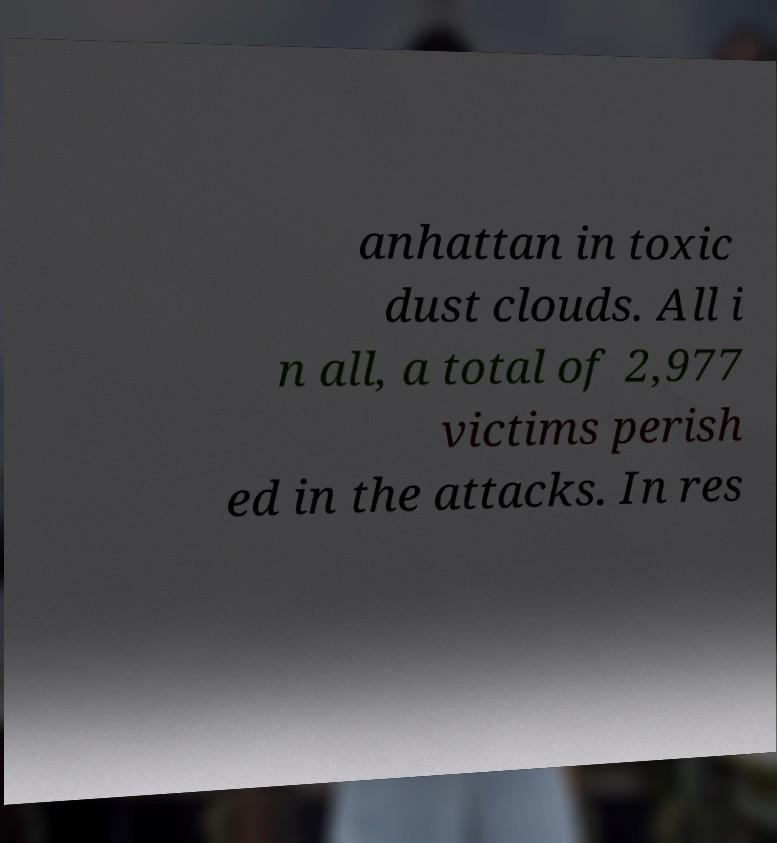Can you read and provide the text displayed in the image?This photo seems to have some interesting text. Can you extract and type it out for me? anhattan in toxic dust clouds. All i n all, a total of 2,977 victims perish ed in the attacks. In res 